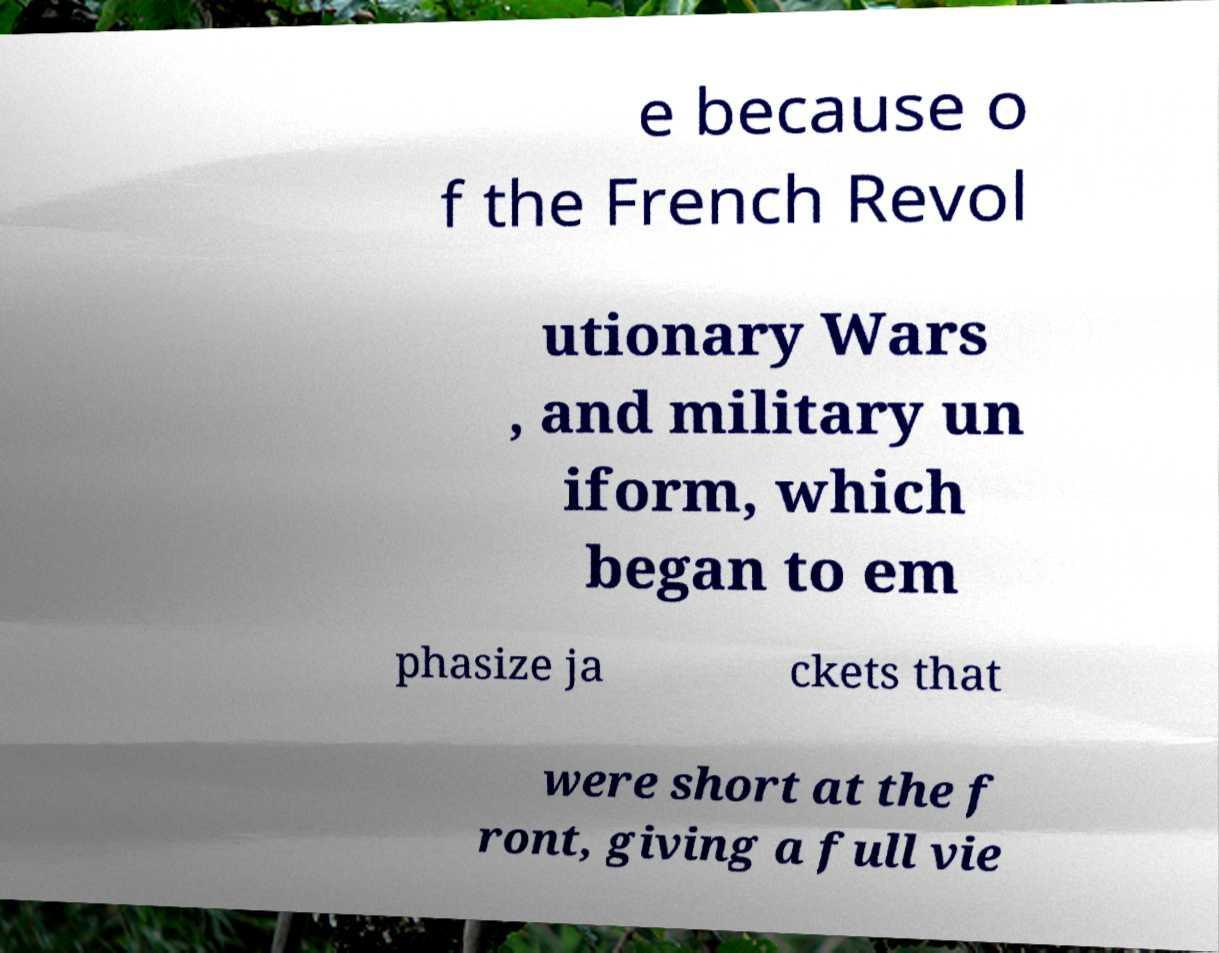Could you assist in decoding the text presented in this image and type it out clearly? e because o f the French Revol utionary Wars , and military un iform, which began to em phasize ja ckets that were short at the f ront, giving a full vie 